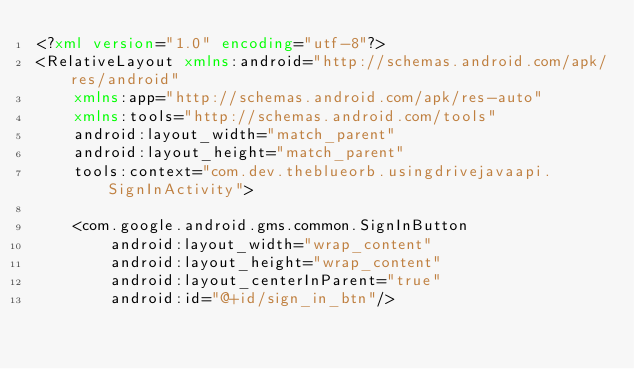<code> <loc_0><loc_0><loc_500><loc_500><_XML_><?xml version="1.0" encoding="utf-8"?>
<RelativeLayout xmlns:android="http://schemas.android.com/apk/res/android"
    xmlns:app="http://schemas.android.com/apk/res-auto"
    xmlns:tools="http://schemas.android.com/tools"
    android:layout_width="match_parent"
    android:layout_height="match_parent"
    tools:context="com.dev.theblueorb.usingdrivejavaapi.SignInActivity">

    <com.google.android.gms.common.SignInButton
        android:layout_width="wrap_content"
        android:layout_height="wrap_content"
        android:layout_centerInParent="true"
        android:id="@+id/sign_in_btn"/></code> 